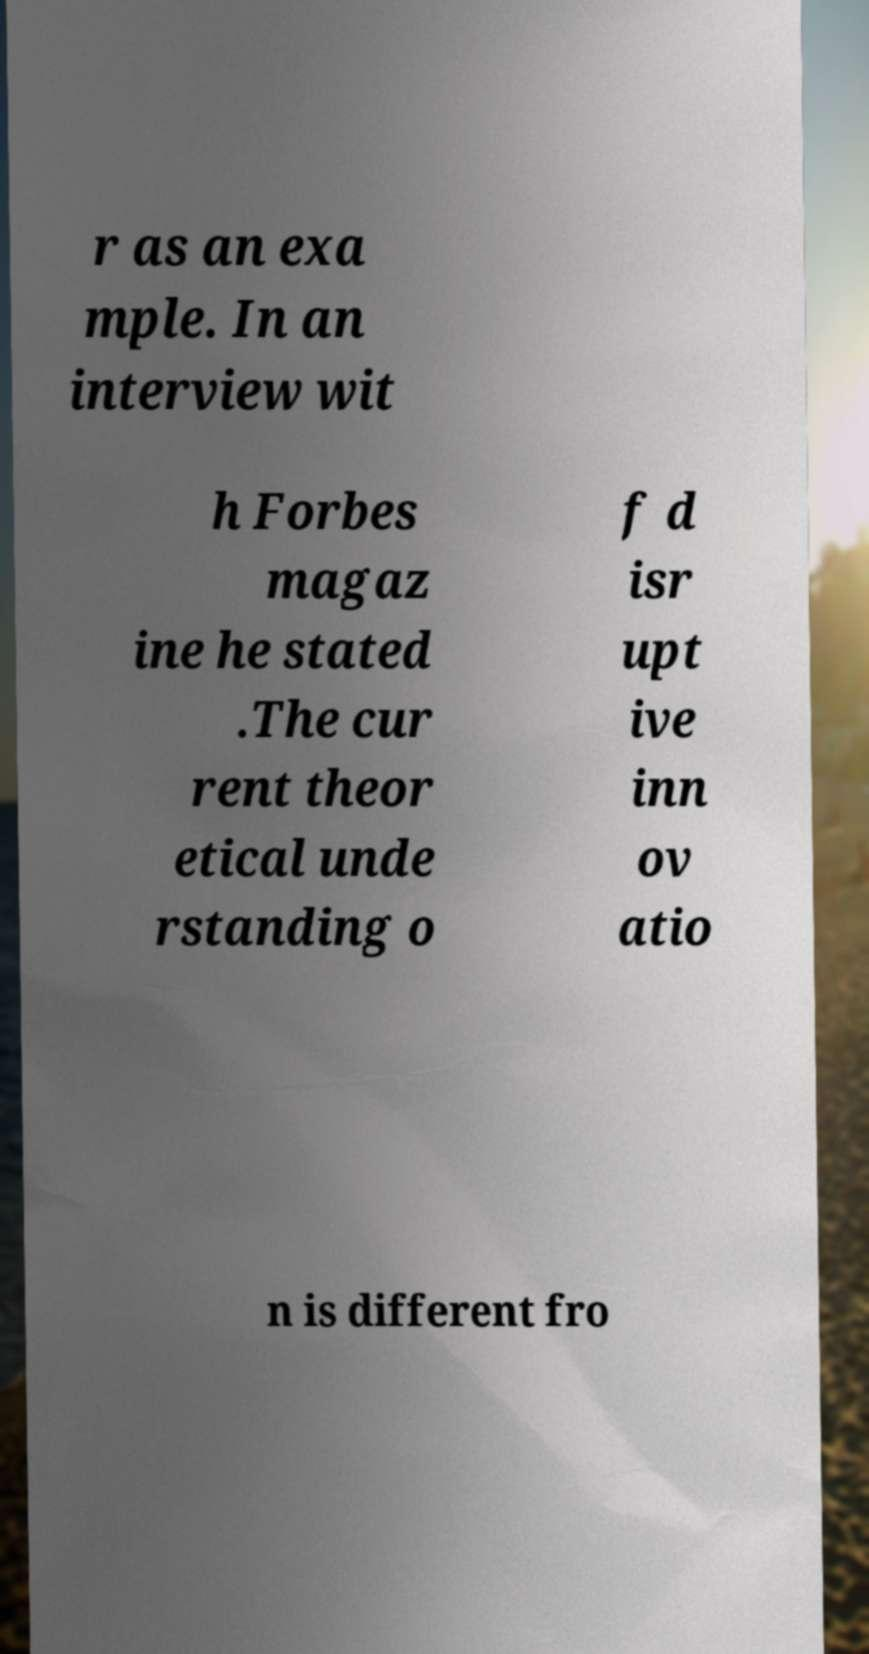Please identify and transcribe the text found in this image. r as an exa mple. In an interview wit h Forbes magaz ine he stated .The cur rent theor etical unde rstanding o f d isr upt ive inn ov atio n is different fro 